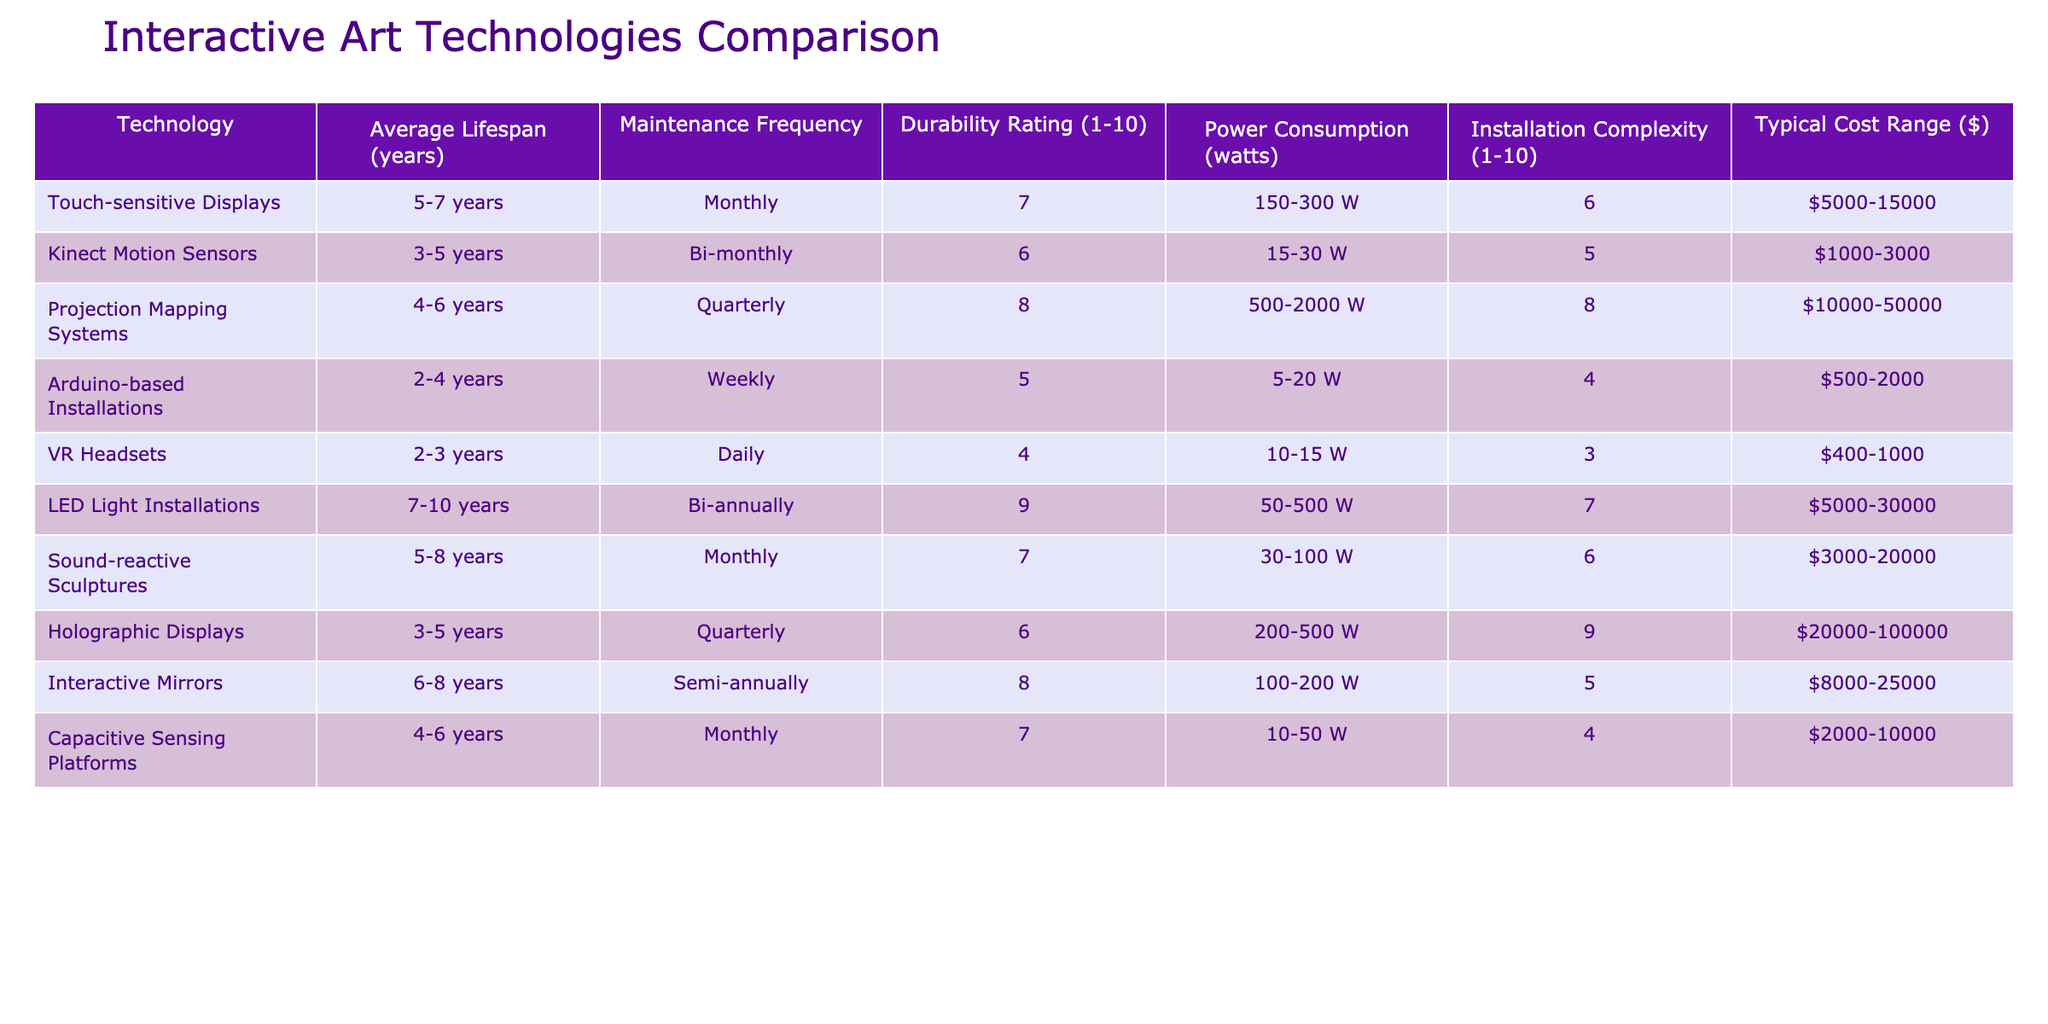What is the average lifespan of Touch-sensitive Displays? According to the table, the average lifespan of Touch-sensitive Displays is between 5-7 years. This is clearly stated in the corresponding row under the "Average Lifespan (years)" column.
Answer: 5-7 years Which technology has the highest durability rating? The technology with the highest durability rating is LED Light Installations, which has a rating of 9. This can be found by comparing the "Durability Rating" values across all technologies listed in the table.
Answer: LED Light Installations What is the total typical cost range for Projection Mapping Systems and Holographic Displays combined? The typical cost for Projection Mapping Systems is $10,000 - $50,000, and for Holographic Displays, it is $20,000 - $100,000. Adding the minimums gives 10,000 + 20,000 = 30,000, and adding the maximums gives 50,000 + 100,000 = 150,000, so the total range is $30,000 - $150,000.
Answer: $30,000 - $150,000 Do all technologies listed consume more than 100 watts of power? No, several technologies consume less than 100 watts. For instance, Kinect Motion Sensors consume between 15-30 watts, while Arduino-based Installations consume 5-20 watts, indicated in the "Power Consumption (watts)" column.
Answer: No What is the average number of years for the lifespan of Arduino-based Installations compared to LED Light Installations? The average lifespan for Arduino-based Installations is calculated as (2+4)/2 = 3 years, while for LED Light Installations, it is (7+10)/2 = 8.5 years. Comparing these values shows that LED Light Installations have a significantly longer lifespan than Arduino-based Installations, with a difference of 5.5 years.
Answer: LED Light Installations (8.5 years) > Arduino-based Installations (3 years) 